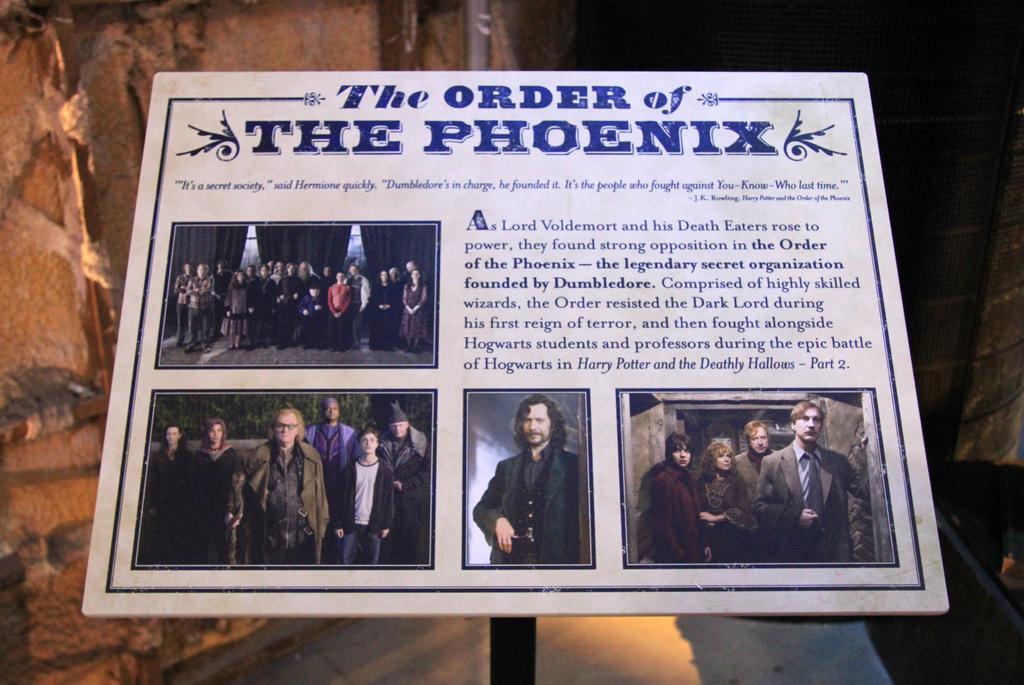What is one of the fictional character names on this board?
Provide a short and direct response. Lord voldemort. Which movie is this about?
Ensure brevity in your answer.  The order of the phoenix. 